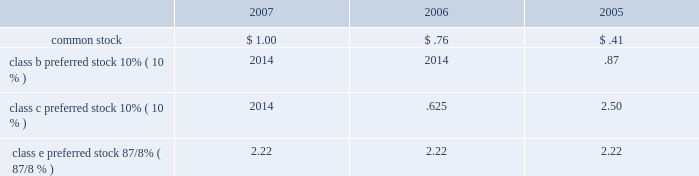Agreements .
Deferred financing costs amounted to $ 51 million and $ 60 million , net of accumulated amortization , as of december 31 , 2007 and 2006 , respectively .
Amortization of deferred financing costs totaled $ 13 million , $ 15 million and $ 14 million in 2007 , 2006 and 2005 , respectively , and is included in interest expense on the accompanying statements of operations .
Amortization of property and equipment under capital leases totaled $ 2 million , $ 2 million and $ 3 million in 2007 , 2006 and 2005 , respectively , and is included in depreciation and amortization on the accompanying consolidated state- ments of operations .
5 stockholders 2019 equity seven hundred fifty million shares of common stock , with a par value of $ 0.01 per share , are authorized , of which 522.6 million and 521.1 million were outstanding as of december 31 , 2007 and 2006 , respectively .
Fifty million shares of no par value preferred stock are authorized , with 4.0 million shares out- standing as of december 31 , 2007 and 2006 .
Dividends we are required to distribute at least 90% ( 90 % ) of our annual taxable income , excluding net capital gain , to qualify as a reit .
However , our policy on common dividends is generally to distribute 100% ( 100 % ) of our estimated annual taxable income , including net capital gain , unless otherwise contractually restricted .
For our preferred dividends , we will generally pay the quarterly dividend , regard- less of the amount of taxable income , unless similarly contractu- ally restricted .
The amount of any dividends will be determined by host 2019s board of directors .
All dividends declared in 2007 , 2006 and 2005 were determined to be ordinary income .
The table below presents the amount of common and preferred dividends declared per share as follows: .
Class e preferred stock 8 7/8% ( 7/8 % ) 2.22 2.22 2.22 common stock on april 10 , 2006 , we issued approximately 133.5 million com- mon shares for the acquisition of hotels from starwood hotels & resorts .
See note 12 , acquisitions-starwood acquisition .
During 2006 , we converted our convertible subordinated debentures into approximately 24 million shares of common stock .
The remainder was redeemed for $ 2 million in april 2006 .
See note 4 , debt .
Preferred stock we currently have one class of publicly-traded preferred stock outstanding : 4034400 shares of 8 7/8% ( 7/8 % ) class e preferred stock .
Holders of the preferred stock are entitled to receive cumulative cash dividends at 8 7/8% ( 7/8 % ) per annum of the $ 25.00 per share liqui- dation preference , which are payable quarterly in arrears .
After june 2 , 2009 , we have the option to redeem the class e preferred stock for $ 25.00 per share , plus accrued and unpaid dividends to the date of redemption .
The preferred stock ranks senior to the common stock and the authorized series a junior participating preferred stock ( discussed below ) .
The preferred stockholders generally have no voting rights .
Accrued preferred dividends at december 31 , 2007 and 2006 were approximately $ 2 million .
During 2006 and 2005 , we redeemed , at par , all of our then outstanding shares of class c and b cumulative preferred stock , respectively .
The fair value of the preferred stock ( which was equal to the redemption price ) exceeded the carrying value of the class c and b preferred stock by approximately $ 6 million and $ 4 million , respectively .
These amounts represent the origi- nal issuance costs .
The original issuance costs for the class c and b preferred stock have been reflected in the determination of net income available to common stockholders for the pur- pose of calculating our basic and diluted earnings per share in the respective years of redemption .
Stockholders rights plan in 1998 , the board of directors adopted a stockholder rights plan under which a dividend of one preferred stock purchase right was distributed for each outstanding share of our com- mon stock .
Each right when exercisable entitles the holder to buy 1/1000th of a share of a series a junior participating pre- ferred stock of ours at an exercise price of $ 55 per share , subject to adjustment .
The rights are exercisable 10 days after a person or group acquired beneficial ownership of at least 20% ( 20 % ) , or began a tender or exchange offer for at least 20% ( 20 % ) , of our com- mon stock .
Shares owned by a person or group on november 3 , 1998 and held continuously thereafter are exempt for purposes of determining beneficial ownership under the rights plan .
The rights are non-voting and expire on november 22 , 2008 , unless exercised or previously redeemed by us for $ .005 each .
If we were involved in a merger or certain other business combina- tions not approved by the board of directors , each right entitles its holder , other than the acquiring person or group , to purchase common stock of either our company or the acquiror having a value of twice the exercise price of the right .
Stock repurchase plan our board of directors has authorized a program to repur- chase up to $ 500 million of common stock .
The common stock may be purchased in the open market or through private trans- actions , dependent upon market conditions .
The plan does not obligate us to repurchase any specific number of shares and may be suspended at any time at management 2019s discretion .
6 income taxes we elected to be treated as a reit effective january 1 , 1999 , pursuant to the u.s .
Internal revenue code of 1986 , as amended .
In general , a corporation that elects reit status and meets certain tax law requirements regarding the distribution of its taxable income to its stockholders as prescribed by applicable tax laws and complies with certain other requirements ( relating primarily to the nature of its assets and the sources of its revenues ) is generally not subject to federal and state income taxation on its operating income distributed to its stockholders .
In addition to paying federal and state income taxes on any retained income , we are subject to taxes on 201cbuilt-in-gains 201d resulting from sales of certain assets .
Additionally , our taxable reit subsidiaries are subject to federal , state and foreign 63h o s t h o t e l s & r e s o r t s 2 0 0 7 60629p21-80x4 4/8/08 4:02 pm page 63 .
What was the percent of the increase in the common stock dividend from 2006 to 2007? 
Rationale: the common stock dividend increased by 316% from 2006 to 2007
Computations: ((1.00 / .76) / .76)
Answer: 1.7313. 